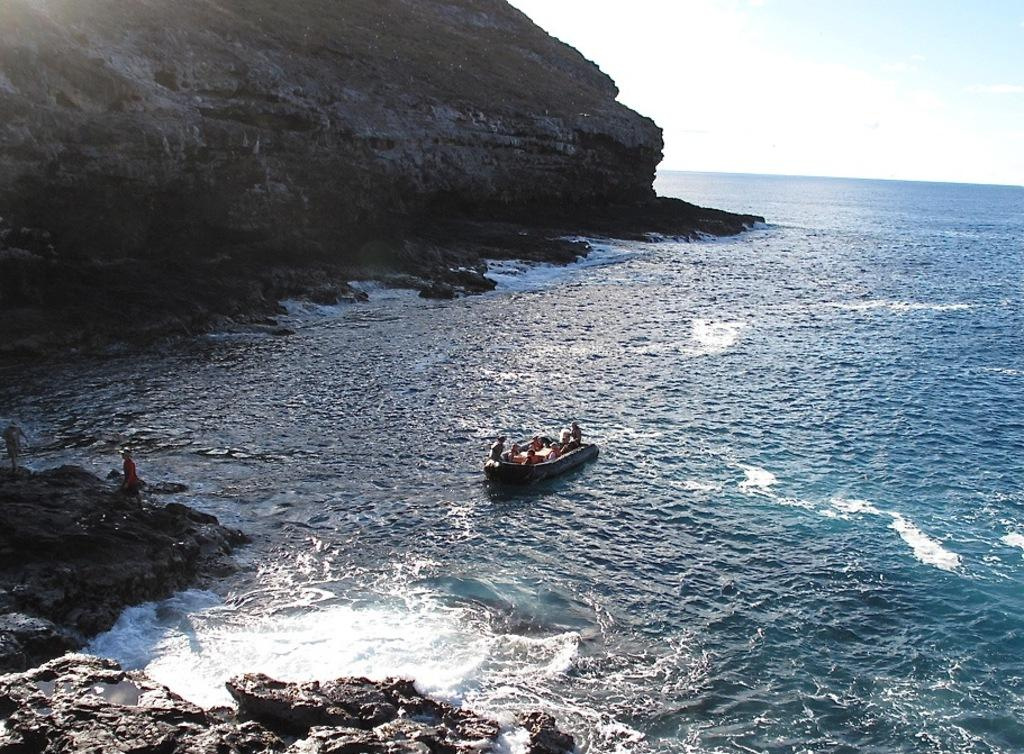What is the main subject in the foreground of the image? There is a boat in the foreground of the image. What is the boat's location in relation to the water? The boat is on the water. What can be seen in the background of the image? There is a cliff and the sky visible in the background of the image. What is the condition of the sky in the image? The sky is visible in the background of the image, and there are clouds present. Can you describe the water in the image? The water is visible in the image, and it is the location of the boat. What type of camera is visible on the cliff in the image? There is no camera visible on the cliff in the image. Is there a tent set up near the boat in the image? There is no tent present in the image; it only features a boat on the water, a cliff, and the sky. 